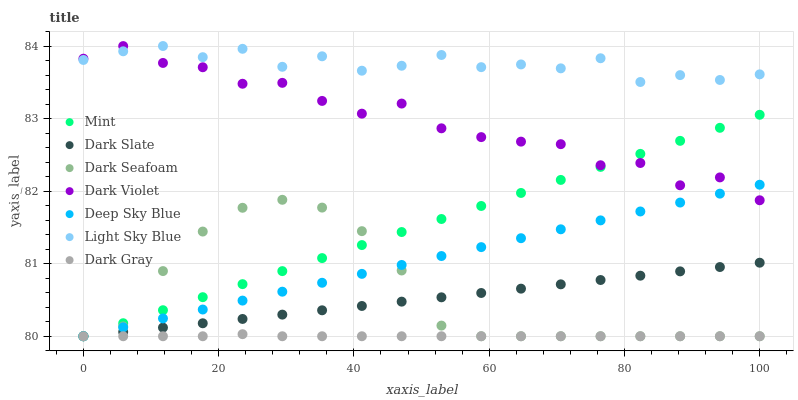Does Dark Gray have the minimum area under the curve?
Answer yes or no. Yes. Does Light Sky Blue have the maximum area under the curve?
Answer yes or no. Yes. Does Dark Slate have the minimum area under the curve?
Answer yes or no. No. Does Dark Slate have the maximum area under the curve?
Answer yes or no. No. Is Deep Sky Blue the smoothest?
Answer yes or no. Yes. Is Dark Violet the roughest?
Answer yes or no. Yes. Is Dark Gray the smoothest?
Answer yes or no. No. Is Dark Gray the roughest?
Answer yes or no. No. Does Dark Gray have the lowest value?
Answer yes or no. Yes. Does Light Sky Blue have the lowest value?
Answer yes or no. No. Does Light Sky Blue have the highest value?
Answer yes or no. Yes. Does Dark Slate have the highest value?
Answer yes or no. No. Is Deep Sky Blue less than Light Sky Blue?
Answer yes or no. Yes. Is Light Sky Blue greater than Dark Gray?
Answer yes or no. Yes. Does Deep Sky Blue intersect Dark Seafoam?
Answer yes or no. Yes. Is Deep Sky Blue less than Dark Seafoam?
Answer yes or no. No. Is Deep Sky Blue greater than Dark Seafoam?
Answer yes or no. No. Does Deep Sky Blue intersect Light Sky Blue?
Answer yes or no. No. 